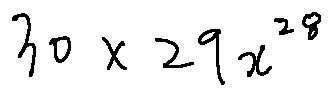Convert formula to latex. <formula><loc_0><loc_0><loc_500><loc_500>3 0 \times 2 9 x ^ { 2 8 }</formula> 